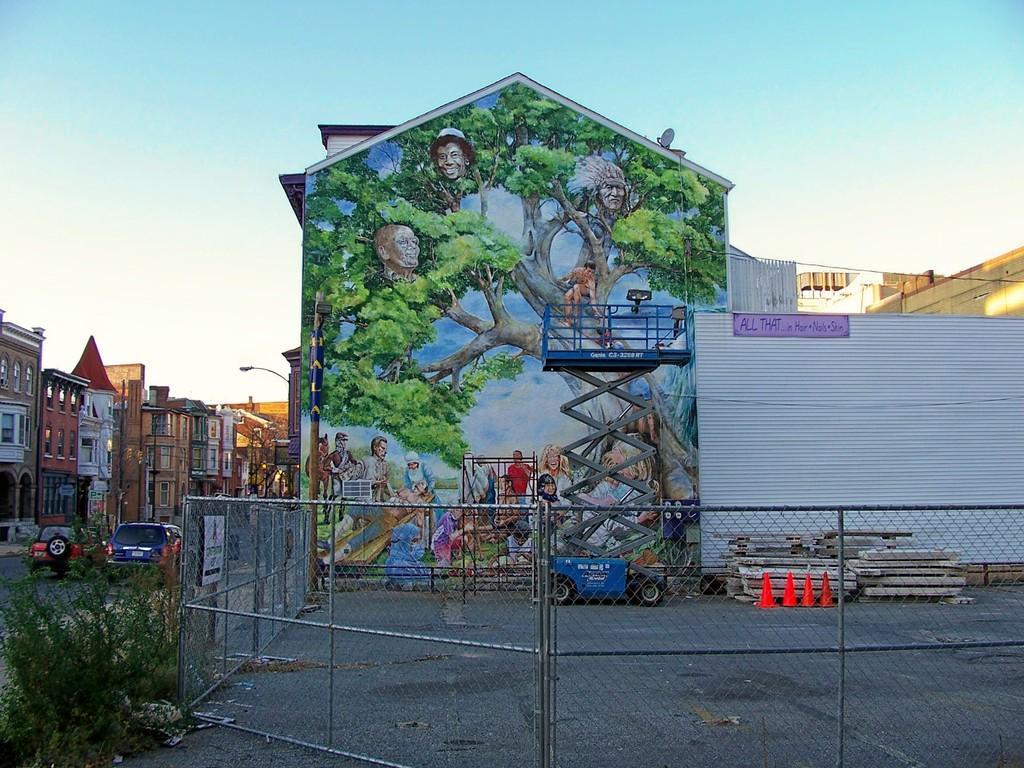Please provide a concise description of this image. In the foreground I can see the metal fence. In the background, I can see the buildings. I can see two cars on the road on the left side. I can see the painting on the wall of the building. I can see the lifting machine and barriers. There are clouds in the sky. 